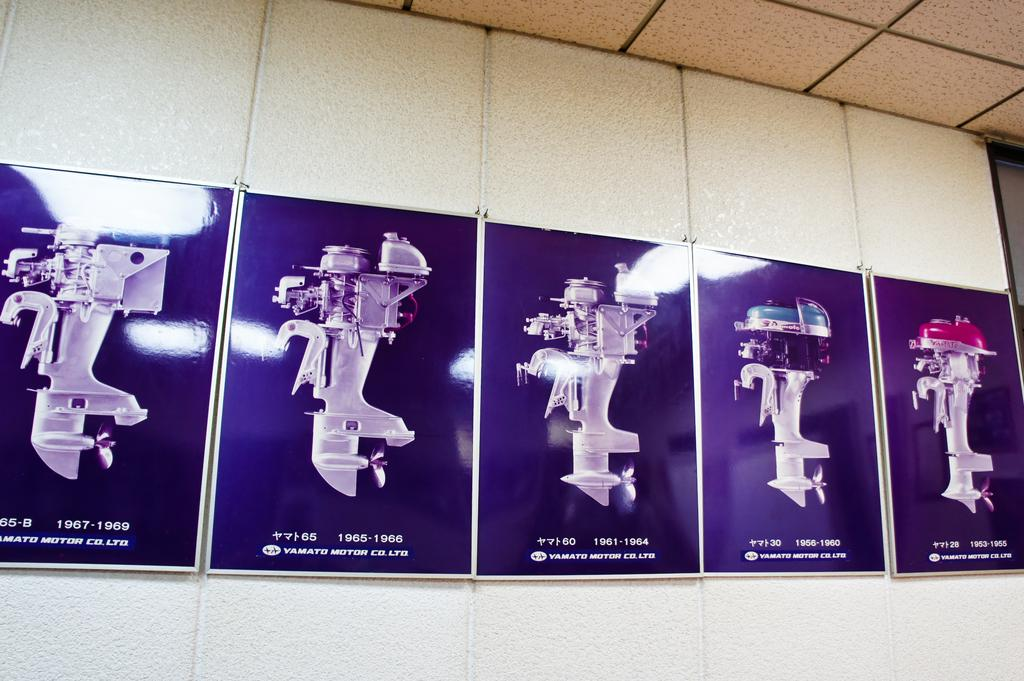What type of images are displayed on the wall in the image? There are photographs of machines on the wall in the image. How many goldfish are swimming in the seat in the image? There are no goldfish or seats present in the image; it only features photographs of machines on the wall. 